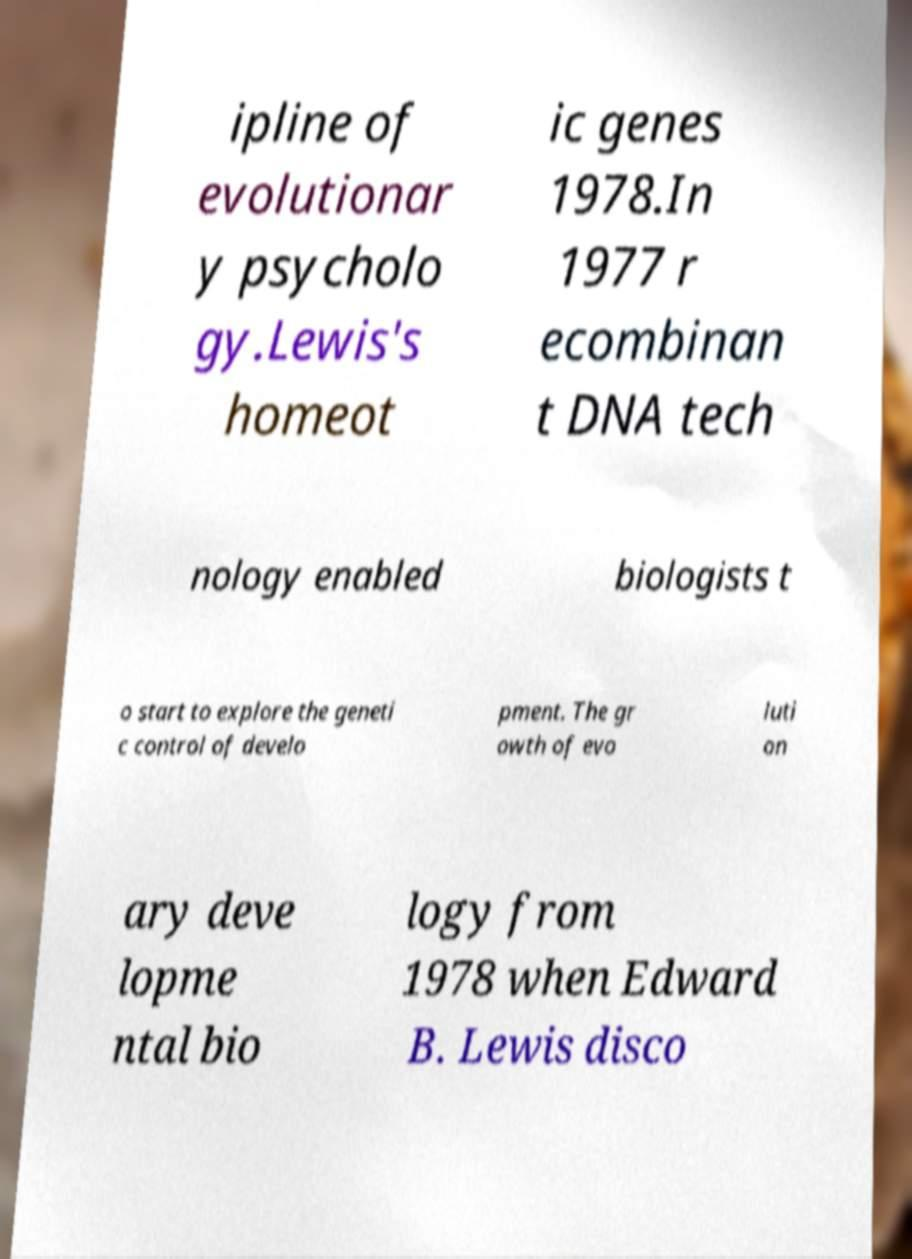For documentation purposes, I need the text within this image transcribed. Could you provide that? ipline of evolutionar y psycholo gy.Lewis's homeot ic genes 1978.In 1977 r ecombinan t DNA tech nology enabled biologists t o start to explore the geneti c control of develo pment. The gr owth of evo luti on ary deve lopme ntal bio logy from 1978 when Edward B. Lewis disco 